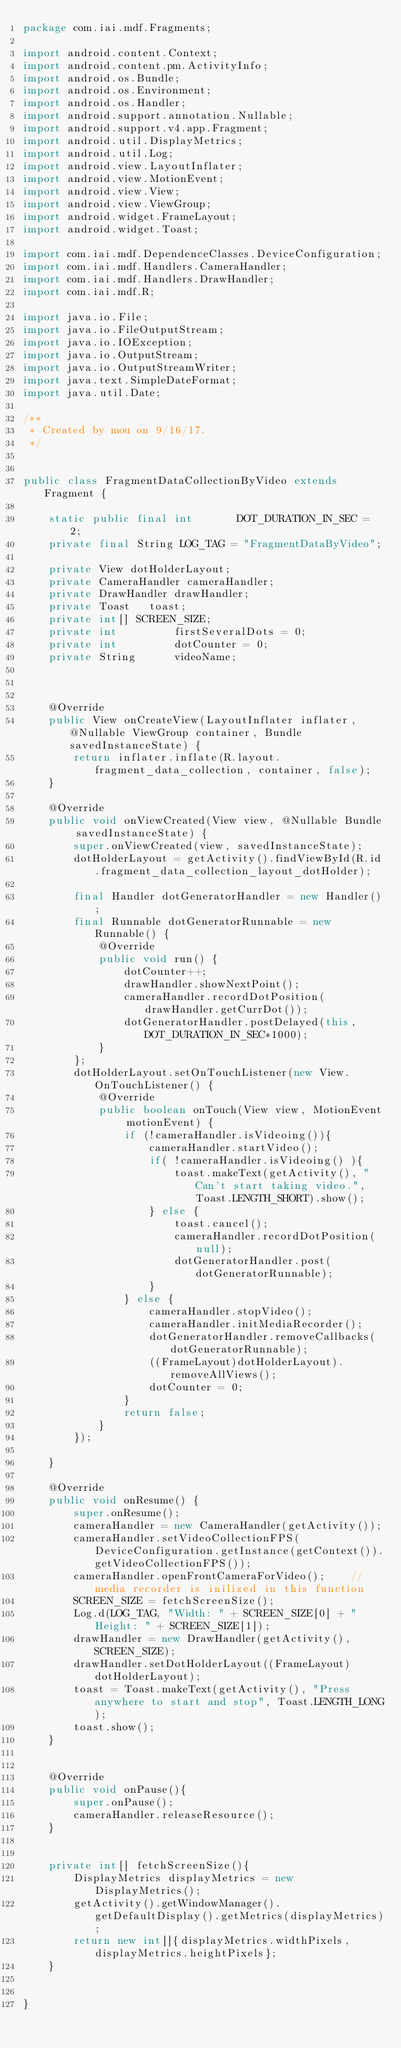<code> <loc_0><loc_0><loc_500><loc_500><_Java_>package com.iai.mdf.Fragments;

import android.content.Context;
import android.content.pm.ActivityInfo;
import android.os.Bundle;
import android.os.Environment;
import android.os.Handler;
import android.support.annotation.Nullable;
import android.support.v4.app.Fragment;
import android.util.DisplayMetrics;
import android.util.Log;
import android.view.LayoutInflater;
import android.view.MotionEvent;
import android.view.View;
import android.view.ViewGroup;
import android.widget.FrameLayout;
import android.widget.Toast;

import com.iai.mdf.DependenceClasses.DeviceConfiguration;
import com.iai.mdf.Handlers.CameraHandler;
import com.iai.mdf.Handlers.DrawHandler;
import com.iai.mdf.R;

import java.io.File;
import java.io.FileOutputStream;
import java.io.IOException;
import java.io.OutputStream;
import java.io.OutputStreamWriter;
import java.text.SimpleDateFormat;
import java.util.Date;

/**
 * Created by mou on 9/16/17.
 */


public class FragmentDataCollectionByVideo extends Fragment {

    static public final int       DOT_DURATION_IN_SEC = 2;
    private final String LOG_TAG = "FragmentDataByVideo";

    private View dotHolderLayout;
    private CameraHandler cameraHandler;
    private DrawHandler drawHandler;
    private Toast   toast;
    private int[] SCREEN_SIZE;
    private int         firstSeveralDots = 0;
    private int         dotCounter = 0;
    private String      videoName;



    @Override
    public View onCreateView(LayoutInflater inflater, @Nullable ViewGroup container, Bundle savedInstanceState) {
        return inflater.inflate(R.layout.fragment_data_collection, container, false);
    }

    @Override
    public void onViewCreated(View view, @Nullable Bundle savedInstanceState) {
        super.onViewCreated(view, savedInstanceState);
        dotHolderLayout = getActivity().findViewById(R.id.fragment_data_collection_layout_dotHolder);

        final Handler dotGeneratorHandler = new Handler();
        final Runnable dotGeneratorRunnable = new Runnable() {
            @Override
            public void run() {
                dotCounter++;
                drawHandler.showNextPoint();
                cameraHandler.recordDotPosition(drawHandler.getCurrDot());
                dotGeneratorHandler.postDelayed(this,DOT_DURATION_IN_SEC*1000);
            }
        };
        dotHolderLayout.setOnTouchListener(new View.OnTouchListener() {
            @Override
            public boolean onTouch(View view, MotionEvent motionEvent) {
                if (!cameraHandler.isVideoing()){
                    cameraHandler.startVideo();
                    if( !cameraHandler.isVideoing() ){
                        toast.makeText(getActivity(), "Can't start taking video.", Toast.LENGTH_SHORT).show();
                    } else {
                        toast.cancel();
                        cameraHandler.recordDotPosition(null);
                        dotGeneratorHandler.post(dotGeneratorRunnable);
                    }
                } else {
                    cameraHandler.stopVideo();
                    cameraHandler.initMediaRecorder();
                    dotGeneratorHandler.removeCallbacks(dotGeneratorRunnable);
                    ((FrameLayout)dotHolderLayout).removeAllViews();
                    dotCounter = 0;
                }
                return false;
            }
        });

    }

    @Override
    public void onResume() {
        super.onResume();
        cameraHandler = new CameraHandler(getActivity());
        cameraHandler.setVideoCollectionFPS(DeviceConfiguration.getInstance(getContext()).getVideoCollectionFPS());
        cameraHandler.openFrontCameraForVideo();    // media recorder is inilized in this function
        SCREEN_SIZE = fetchScreenSize();
        Log.d(LOG_TAG, "Width: " + SCREEN_SIZE[0] + "    Height: " + SCREEN_SIZE[1]);
        drawHandler = new DrawHandler(getActivity(), SCREEN_SIZE);
        drawHandler.setDotHolderLayout((FrameLayout)dotHolderLayout);
        toast = Toast.makeText(getActivity(), "Press anywhere to start and stop", Toast.LENGTH_LONG);
        toast.show();
    }


    @Override
    public void onPause(){
        super.onPause();
        cameraHandler.releaseResource();
    }


    private int[] fetchScreenSize(){
        DisplayMetrics displayMetrics = new DisplayMetrics();
        getActivity().getWindowManager().getDefaultDisplay().getMetrics(displayMetrics);
        return new int[]{displayMetrics.widthPixels, displayMetrics.heightPixels};
    }


}
</code> 